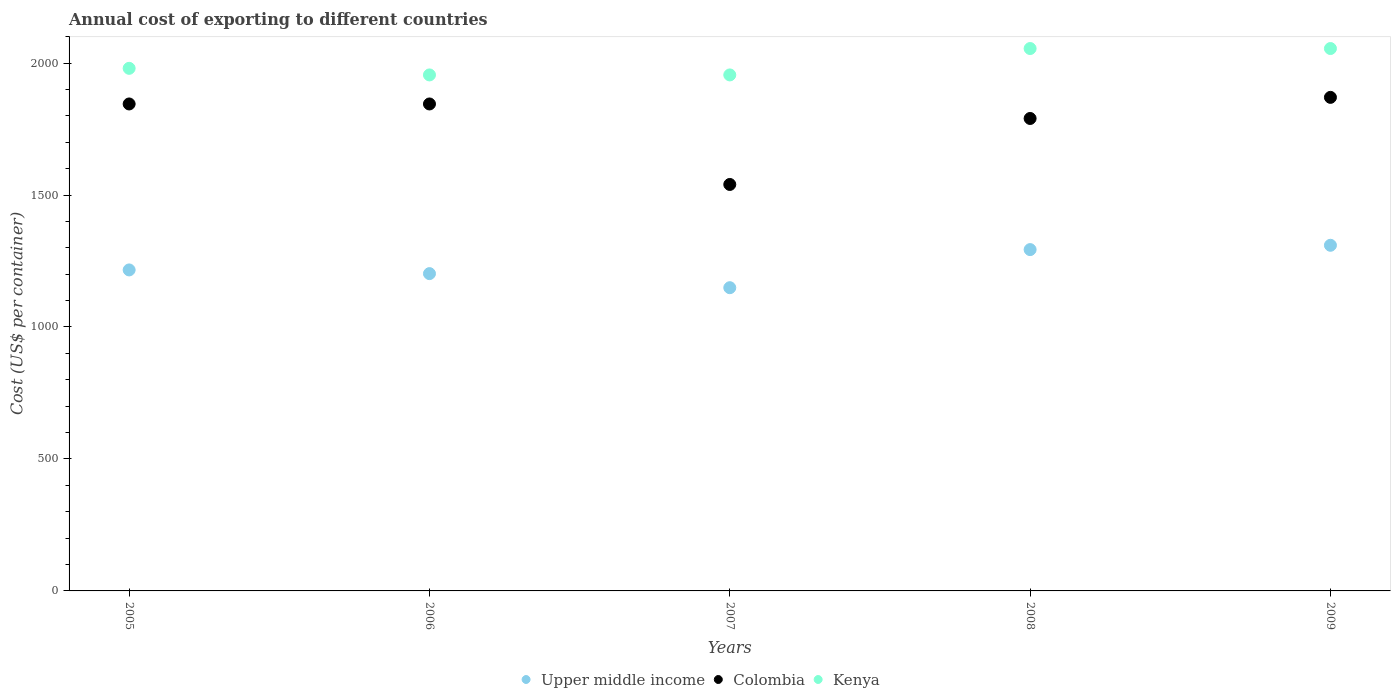How many different coloured dotlines are there?
Your response must be concise. 3. What is the total annual cost of exporting in Kenya in 2009?
Keep it short and to the point. 2055. Across all years, what is the maximum total annual cost of exporting in Upper middle income?
Ensure brevity in your answer.  1309.58. Across all years, what is the minimum total annual cost of exporting in Upper middle income?
Your answer should be compact. 1148.88. What is the total total annual cost of exporting in Colombia in the graph?
Offer a terse response. 8890. What is the difference between the total annual cost of exporting in Kenya in 2005 and the total annual cost of exporting in Upper middle income in 2009?
Offer a very short reply. 670.42. In the year 2009, what is the difference between the total annual cost of exporting in Colombia and total annual cost of exporting in Upper middle income?
Your response must be concise. 560.42. What is the ratio of the total annual cost of exporting in Colombia in 2005 to that in 2009?
Your answer should be compact. 0.99. Is the total annual cost of exporting in Kenya in 2006 less than that in 2009?
Give a very brief answer. Yes. What is the difference between the highest and the second highest total annual cost of exporting in Colombia?
Offer a terse response. 25. What is the difference between the highest and the lowest total annual cost of exporting in Colombia?
Make the answer very short. 330. Is it the case that in every year, the sum of the total annual cost of exporting in Colombia and total annual cost of exporting in Kenya  is greater than the total annual cost of exporting in Upper middle income?
Keep it short and to the point. Yes. Is the total annual cost of exporting in Upper middle income strictly greater than the total annual cost of exporting in Kenya over the years?
Your answer should be compact. No. How many dotlines are there?
Provide a succinct answer. 3. How many years are there in the graph?
Make the answer very short. 5. What is the difference between two consecutive major ticks on the Y-axis?
Offer a very short reply. 500. Are the values on the major ticks of Y-axis written in scientific E-notation?
Offer a terse response. No. Does the graph contain any zero values?
Your response must be concise. No. Does the graph contain grids?
Offer a terse response. No. How are the legend labels stacked?
Provide a succinct answer. Horizontal. What is the title of the graph?
Provide a short and direct response. Annual cost of exporting to different countries. What is the label or title of the Y-axis?
Your response must be concise. Cost (US$ per container). What is the Cost (US$ per container) in Upper middle income in 2005?
Keep it short and to the point. 1216.17. What is the Cost (US$ per container) in Colombia in 2005?
Provide a short and direct response. 1845. What is the Cost (US$ per container) of Kenya in 2005?
Your answer should be very brief. 1980. What is the Cost (US$ per container) in Upper middle income in 2006?
Offer a very short reply. 1202.19. What is the Cost (US$ per container) of Colombia in 2006?
Offer a very short reply. 1845. What is the Cost (US$ per container) in Kenya in 2006?
Your answer should be compact. 1955. What is the Cost (US$ per container) in Upper middle income in 2007?
Your response must be concise. 1148.88. What is the Cost (US$ per container) in Colombia in 2007?
Offer a very short reply. 1540. What is the Cost (US$ per container) in Kenya in 2007?
Your answer should be compact. 1955. What is the Cost (US$ per container) of Upper middle income in 2008?
Provide a succinct answer. 1293.21. What is the Cost (US$ per container) of Colombia in 2008?
Provide a succinct answer. 1790. What is the Cost (US$ per container) of Kenya in 2008?
Your response must be concise. 2055. What is the Cost (US$ per container) of Upper middle income in 2009?
Ensure brevity in your answer.  1309.58. What is the Cost (US$ per container) in Colombia in 2009?
Your response must be concise. 1870. What is the Cost (US$ per container) of Kenya in 2009?
Provide a succinct answer. 2055. Across all years, what is the maximum Cost (US$ per container) in Upper middle income?
Offer a terse response. 1309.58. Across all years, what is the maximum Cost (US$ per container) in Colombia?
Offer a terse response. 1870. Across all years, what is the maximum Cost (US$ per container) of Kenya?
Provide a succinct answer. 2055. Across all years, what is the minimum Cost (US$ per container) in Upper middle income?
Offer a very short reply. 1148.88. Across all years, what is the minimum Cost (US$ per container) in Colombia?
Provide a short and direct response. 1540. Across all years, what is the minimum Cost (US$ per container) of Kenya?
Offer a very short reply. 1955. What is the total Cost (US$ per container) of Upper middle income in the graph?
Offer a very short reply. 6170.02. What is the total Cost (US$ per container) of Colombia in the graph?
Give a very brief answer. 8890. What is the difference between the Cost (US$ per container) in Upper middle income in 2005 and that in 2006?
Offer a very short reply. 13.98. What is the difference between the Cost (US$ per container) of Colombia in 2005 and that in 2006?
Provide a short and direct response. 0. What is the difference between the Cost (US$ per container) of Upper middle income in 2005 and that in 2007?
Your answer should be compact. 67.3. What is the difference between the Cost (US$ per container) in Colombia in 2005 and that in 2007?
Give a very brief answer. 305. What is the difference between the Cost (US$ per container) in Kenya in 2005 and that in 2007?
Offer a terse response. 25. What is the difference between the Cost (US$ per container) in Upper middle income in 2005 and that in 2008?
Give a very brief answer. -77.04. What is the difference between the Cost (US$ per container) of Kenya in 2005 and that in 2008?
Your answer should be very brief. -75. What is the difference between the Cost (US$ per container) in Upper middle income in 2005 and that in 2009?
Ensure brevity in your answer.  -93.41. What is the difference between the Cost (US$ per container) of Kenya in 2005 and that in 2009?
Ensure brevity in your answer.  -75. What is the difference between the Cost (US$ per container) in Upper middle income in 2006 and that in 2007?
Offer a very short reply. 53.31. What is the difference between the Cost (US$ per container) in Colombia in 2006 and that in 2007?
Give a very brief answer. 305. What is the difference between the Cost (US$ per container) of Kenya in 2006 and that in 2007?
Provide a short and direct response. 0. What is the difference between the Cost (US$ per container) in Upper middle income in 2006 and that in 2008?
Keep it short and to the point. -91.02. What is the difference between the Cost (US$ per container) in Kenya in 2006 and that in 2008?
Provide a succinct answer. -100. What is the difference between the Cost (US$ per container) of Upper middle income in 2006 and that in 2009?
Keep it short and to the point. -107.4. What is the difference between the Cost (US$ per container) of Kenya in 2006 and that in 2009?
Your answer should be very brief. -100. What is the difference between the Cost (US$ per container) in Upper middle income in 2007 and that in 2008?
Give a very brief answer. -144.33. What is the difference between the Cost (US$ per container) of Colombia in 2007 and that in 2008?
Offer a very short reply. -250. What is the difference between the Cost (US$ per container) of Kenya in 2007 and that in 2008?
Make the answer very short. -100. What is the difference between the Cost (US$ per container) of Upper middle income in 2007 and that in 2009?
Your response must be concise. -160.71. What is the difference between the Cost (US$ per container) of Colombia in 2007 and that in 2009?
Make the answer very short. -330. What is the difference between the Cost (US$ per container) in Kenya in 2007 and that in 2009?
Your answer should be very brief. -100. What is the difference between the Cost (US$ per container) of Upper middle income in 2008 and that in 2009?
Your response must be concise. -16.38. What is the difference between the Cost (US$ per container) in Colombia in 2008 and that in 2009?
Provide a short and direct response. -80. What is the difference between the Cost (US$ per container) in Kenya in 2008 and that in 2009?
Ensure brevity in your answer.  0. What is the difference between the Cost (US$ per container) in Upper middle income in 2005 and the Cost (US$ per container) in Colombia in 2006?
Offer a terse response. -628.83. What is the difference between the Cost (US$ per container) of Upper middle income in 2005 and the Cost (US$ per container) of Kenya in 2006?
Make the answer very short. -738.83. What is the difference between the Cost (US$ per container) in Colombia in 2005 and the Cost (US$ per container) in Kenya in 2006?
Keep it short and to the point. -110. What is the difference between the Cost (US$ per container) of Upper middle income in 2005 and the Cost (US$ per container) of Colombia in 2007?
Offer a terse response. -323.83. What is the difference between the Cost (US$ per container) in Upper middle income in 2005 and the Cost (US$ per container) in Kenya in 2007?
Your answer should be very brief. -738.83. What is the difference between the Cost (US$ per container) of Colombia in 2005 and the Cost (US$ per container) of Kenya in 2007?
Ensure brevity in your answer.  -110. What is the difference between the Cost (US$ per container) in Upper middle income in 2005 and the Cost (US$ per container) in Colombia in 2008?
Provide a short and direct response. -573.83. What is the difference between the Cost (US$ per container) in Upper middle income in 2005 and the Cost (US$ per container) in Kenya in 2008?
Make the answer very short. -838.83. What is the difference between the Cost (US$ per container) of Colombia in 2005 and the Cost (US$ per container) of Kenya in 2008?
Your answer should be compact. -210. What is the difference between the Cost (US$ per container) in Upper middle income in 2005 and the Cost (US$ per container) in Colombia in 2009?
Provide a short and direct response. -653.83. What is the difference between the Cost (US$ per container) in Upper middle income in 2005 and the Cost (US$ per container) in Kenya in 2009?
Make the answer very short. -838.83. What is the difference between the Cost (US$ per container) of Colombia in 2005 and the Cost (US$ per container) of Kenya in 2009?
Offer a very short reply. -210. What is the difference between the Cost (US$ per container) of Upper middle income in 2006 and the Cost (US$ per container) of Colombia in 2007?
Your response must be concise. -337.81. What is the difference between the Cost (US$ per container) of Upper middle income in 2006 and the Cost (US$ per container) of Kenya in 2007?
Your response must be concise. -752.81. What is the difference between the Cost (US$ per container) in Colombia in 2006 and the Cost (US$ per container) in Kenya in 2007?
Ensure brevity in your answer.  -110. What is the difference between the Cost (US$ per container) of Upper middle income in 2006 and the Cost (US$ per container) of Colombia in 2008?
Provide a short and direct response. -587.81. What is the difference between the Cost (US$ per container) in Upper middle income in 2006 and the Cost (US$ per container) in Kenya in 2008?
Your answer should be very brief. -852.81. What is the difference between the Cost (US$ per container) of Colombia in 2006 and the Cost (US$ per container) of Kenya in 2008?
Offer a terse response. -210. What is the difference between the Cost (US$ per container) in Upper middle income in 2006 and the Cost (US$ per container) in Colombia in 2009?
Provide a succinct answer. -667.81. What is the difference between the Cost (US$ per container) of Upper middle income in 2006 and the Cost (US$ per container) of Kenya in 2009?
Make the answer very short. -852.81. What is the difference between the Cost (US$ per container) in Colombia in 2006 and the Cost (US$ per container) in Kenya in 2009?
Offer a terse response. -210. What is the difference between the Cost (US$ per container) in Upper middle income in 2007 and the Cost (US$ per container) in Colombia in 2008?
Your answer should be very brief. -641.12. What is the difference between the Cost (US$ per container) in Upper middle income in 2007 and the Cost (US$ per container) in Kenya in 2008?
Provide a succinct answer. -906.12. What is the difference between the Cost (US$ per container) of Colombia in 2007 and the Cost (US$ per container) of Kenya in 2008?
Offer a terse response. -515. What is the difference between the Cost (US$ per container) of Upper middle income in 2007 and the Cost (US$ per container) of Colombia in 2009?
Provide a short and direct response. -721.12. What is the difference between the Cost (US$ per container) of Upper middle income in 2007 and the Cost (US$ per container) of Kenya in 2009?
Your answer should be compact. -906.12. What is the difference between the Cost (US$ per container) of Colombia in 2007 and the Cost (US$ per container) of Kenya in 2009?
Ensure brevity in your answer.  -515. What is the difference between the Cost (US$ per container) in Upper middle income in 2008 and the Cost (US$ per container) in Colombia in 2009?
Provide a short and direct response. -576.79. What is the difference between the Cost (US$ per container) of Upper middle income in 2008 and the Cost (US$ per container) of Kenya in 2009?
Provide a succinct answer. -761.79. What is the difference between the Cost (US$ per container) of Colombia in 2008 and the Cost (US$ per container) of Kenya in 2009?
Offer a terse response. -265. What is the average Cost (US$ per container) in Upper middle income per year?
Your response must be concise. 1234. What is the average Cost (US$ per container) of Colombia per year?
Offer a very short reply. 1778. In the year 2005, what is the difference between the Cost (US$ per container) of Upper middle income and Cost (US$ per container) of Colombia?
Keep it short and to the point. -628.83. In the year 2005, what is the difference between the Cost (US$ per container) of Upper middle income and Cost (US$ per container) of Kenya?
Offer a very short reply. -763.83. In the year 2005, what is the difference between the Cost (US$ per container) of Colombia and Cost (US$ per container) of Kenya?
Give a very brief answer. -135. In the year 2006, what is the difference between the Cost (US$ per container) in Upper middle income and Cost (US$ per container) in Colombia?
Keep it short and to the point. -642.81. In the year 2006, what is the difference between the Cost (US$ per container) in Upper middle income and Cost (US$ per container) in Kenya?
Provide a succinct answer. -752.81. In the year 2006, what is the difference between the Cost (US$ per container) of Colombia and Cost (US$ per container) of Kenya?
Give a very brief answer. -110. In the year 2007, what is the difference between the Cost (US$ per container) in Upper middle income and Cost (US$ per container) in Colombia?
Ensure brevity in your answer.  -391.12. In the year 2007, what is the difference between the Cost (US$ per container) in Upper middle income and Cost (US$ per container) in Kenya?
Keep it short and to the point. -806.12. In the year 2007, what is the difference between the Cost (US$ per container) in Colombia and Cost (US$ per container) in Kenya?
Offer a terse response. -415. In the year 2008, what is the difference between the Cost (US$ per container) of Upper middle income and Cost (US$ per container) of Colombia?
Provide a succinct answer. -496.79. In the year 2008, what is the difference between the Cost (US$ per container) of Upper middle income and Cost (US$ per container) of Kenya?
Provide a short and direct response. -761.79. In the year 2008, what is the difference between the Cost (US$ per container) of Colombia and Cost (US$ per container) of Kenya?
Keep it short and to the point. -265. In the year 2009, what is the difference between the Cost (US$ per container) in Upper middle income and Cost (US$ per container) in Colombia?
Ensure brevity in your answer.  -560.42. In the year 2009, what is the difference between the Cost (US$ per container) in Upper middle income and Cost (US$ per container) in Kenya?
Ensure brevity in your answer.  -745.42. In the year 2009, what is the difference between the Cost (US$ per container) in Colombia and Cost (US$ per container) in Kenya?
Ensure brevity in your answer.  -185. What is the ratio of the Cost (US$ per container) of Upper middle income in 2005 to that in 2006?
Your response must be concise. 1.01. What is the ratio of the Cost (US$ per container) in Kenya in 2005 to that in 2006?
Your answer should be compact. 1.01. What is the ratio of the Cost (US$ per container) in Upper middle income in 2005 to that in 2007?
Provide a short and direct response. 1.06. What is the ratio of the Cost (US$ per container) of Colombia in 2005 to that in 2007?
Your response must be concise. 1.2. What is the ratio of the Cost (US$ per container) of Kenya in 2005 to that in 2007?
Provide a succinct answer. 1.01. What is the ratio of the Cost (US$ per container) of Upper middle income in 2005 to that in 2008?
Your answer should be very brief. 0.94. What is the ratio of the Cost (US$ per container) of Colombia in 2005 to that in 2008?
Give a very brief answer. 1.03. What is the ratio of the Cost (US$ per container) of Kenya in 2005 to that in 2008?
Your response must be concise. 0.96. What is the ratio of the Cost (US$ per container) of Upper middle income in 2005 to that in 2009?
Offer a very short reply. 0.93. What is the ratio of the Cost (US$ per container) of Colombia in 2005 to that in 2009?
Your answer should be compact. 0.99. What is the ratio of the Cost (US$ per container) in Kenya in 2005 to that in 2009?
Make the answer very short. 0.96. What is the ratio of the Cost (US$ per container) of Upper middle income in 2006 to that in 2007?
Your response must be concise. 1.05. What is the ratio of the Cost (US$ per container) of Colombia in 2006 to that in 2007?
Keep it short and to the point. 1.2. What is the ratio of the Cost (US$ per container) in Kenya in 2006 to that in 2007?
Your answer should be very brief. 1. What is the ratio of the Cost (US$ per container) in Upper middle income in 2006 to that in 2008?
Give a very brief answer. 0.93. What is the ratio of the Cost (US$ per container) of Colombia in 2006 to that in 2008?
Keep it short and to the point. 1.03. What is the ratio of the Cost (US$ per container) in Kenya in 2006 to that in 2008?
Provide a short and direct response. 0.95. What is the ratio of the Cost (US$ per container) of Upper middle income in 2006 to that in 2009?
Give a very brief answer. 0.92. What is the ratio of the Cost (US$ per container) of Colombia in 2006 to that in 2009?
Make the answer very short. 0.99. What is the ratio of the Cost (US$ per container) of Kenya in 2006 to that in 2009?
Ensure brevity in your answer.  0.95. What is the ratio of the Cost (US$ per container) in Upper middle income in 2007 to that in 2008?
Ensure brevity in your answer.  0.89. What is the ratio of the Cost (US$ per container) of Colombia in 2007 to that in 2008?
Offer a terse response. 0.86. What is the ratio of the Cost (US$ per container) in Kenya in 2007 to that in 2008?
Your answer should be very brief. 0.95. What is the ratio of the Cost (US$ per container) of Upper middle income in 2007 to that in 2009?
Make the answer very short. 0.88. What is the ratio of the Cost (US$ per container) of Colombia in 2007 to that in 2009?
Your answer should be compact. 0.82. What is the ratio of the Cost (US$ per container) in Kenya in 2007 to that in 2009?
Make the answer very short. 0.95. What is the ratio of the Cost (US$ per container) of Upper middle income in 2008 to that in 2009?
Your answer should be very brief. 0.99. What is the ratio of the Cost (US$ per container) of Colombia in 2008 to that in 2009?
Keep it short and to the point. 0.96. What is the difference between the highest and the second highest Cost (US$ per container) in Upper middle income?
Keep it short and to the point. 16.38. What is the difference between the highest and the second highest Cost (US$ per container) of Kenya?
Give a very brief answer. 0. What is the difference between the highest and the lowest Cost (US$ per container) in Upper middle income?
Offer a very short reply. 160.71. What is the difference between the highest and the lowest Cost (US$ per container) of Colombia?
Ensure brevity in your answer.  330. 